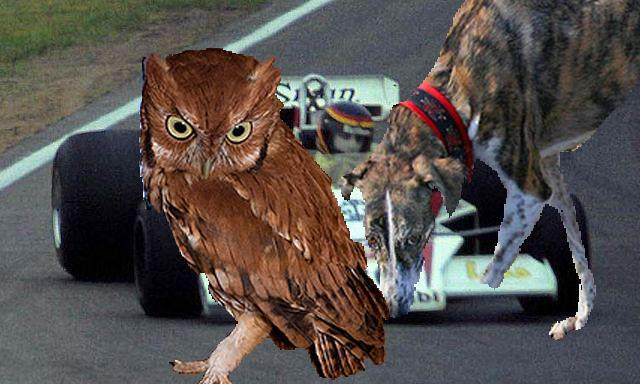Describe the background of this image, please. The background of the image showcases a racing car speeding along a track. The setting implies motion and competition, a sharp contrast to the stillness often associated with the animals in the foreground.  How do the elements in this image relate to each other? In this composition, the elements create a sense of whimsy and surprise. The natural and serene presence of the animals is humorously placed in a context of speed and human achievement, offering a playful take on the juxtaposition of nature with human inventions. It could be interpreted as a light-hearted reminder not to take ourselves too seriously, despite our technological advancements. 